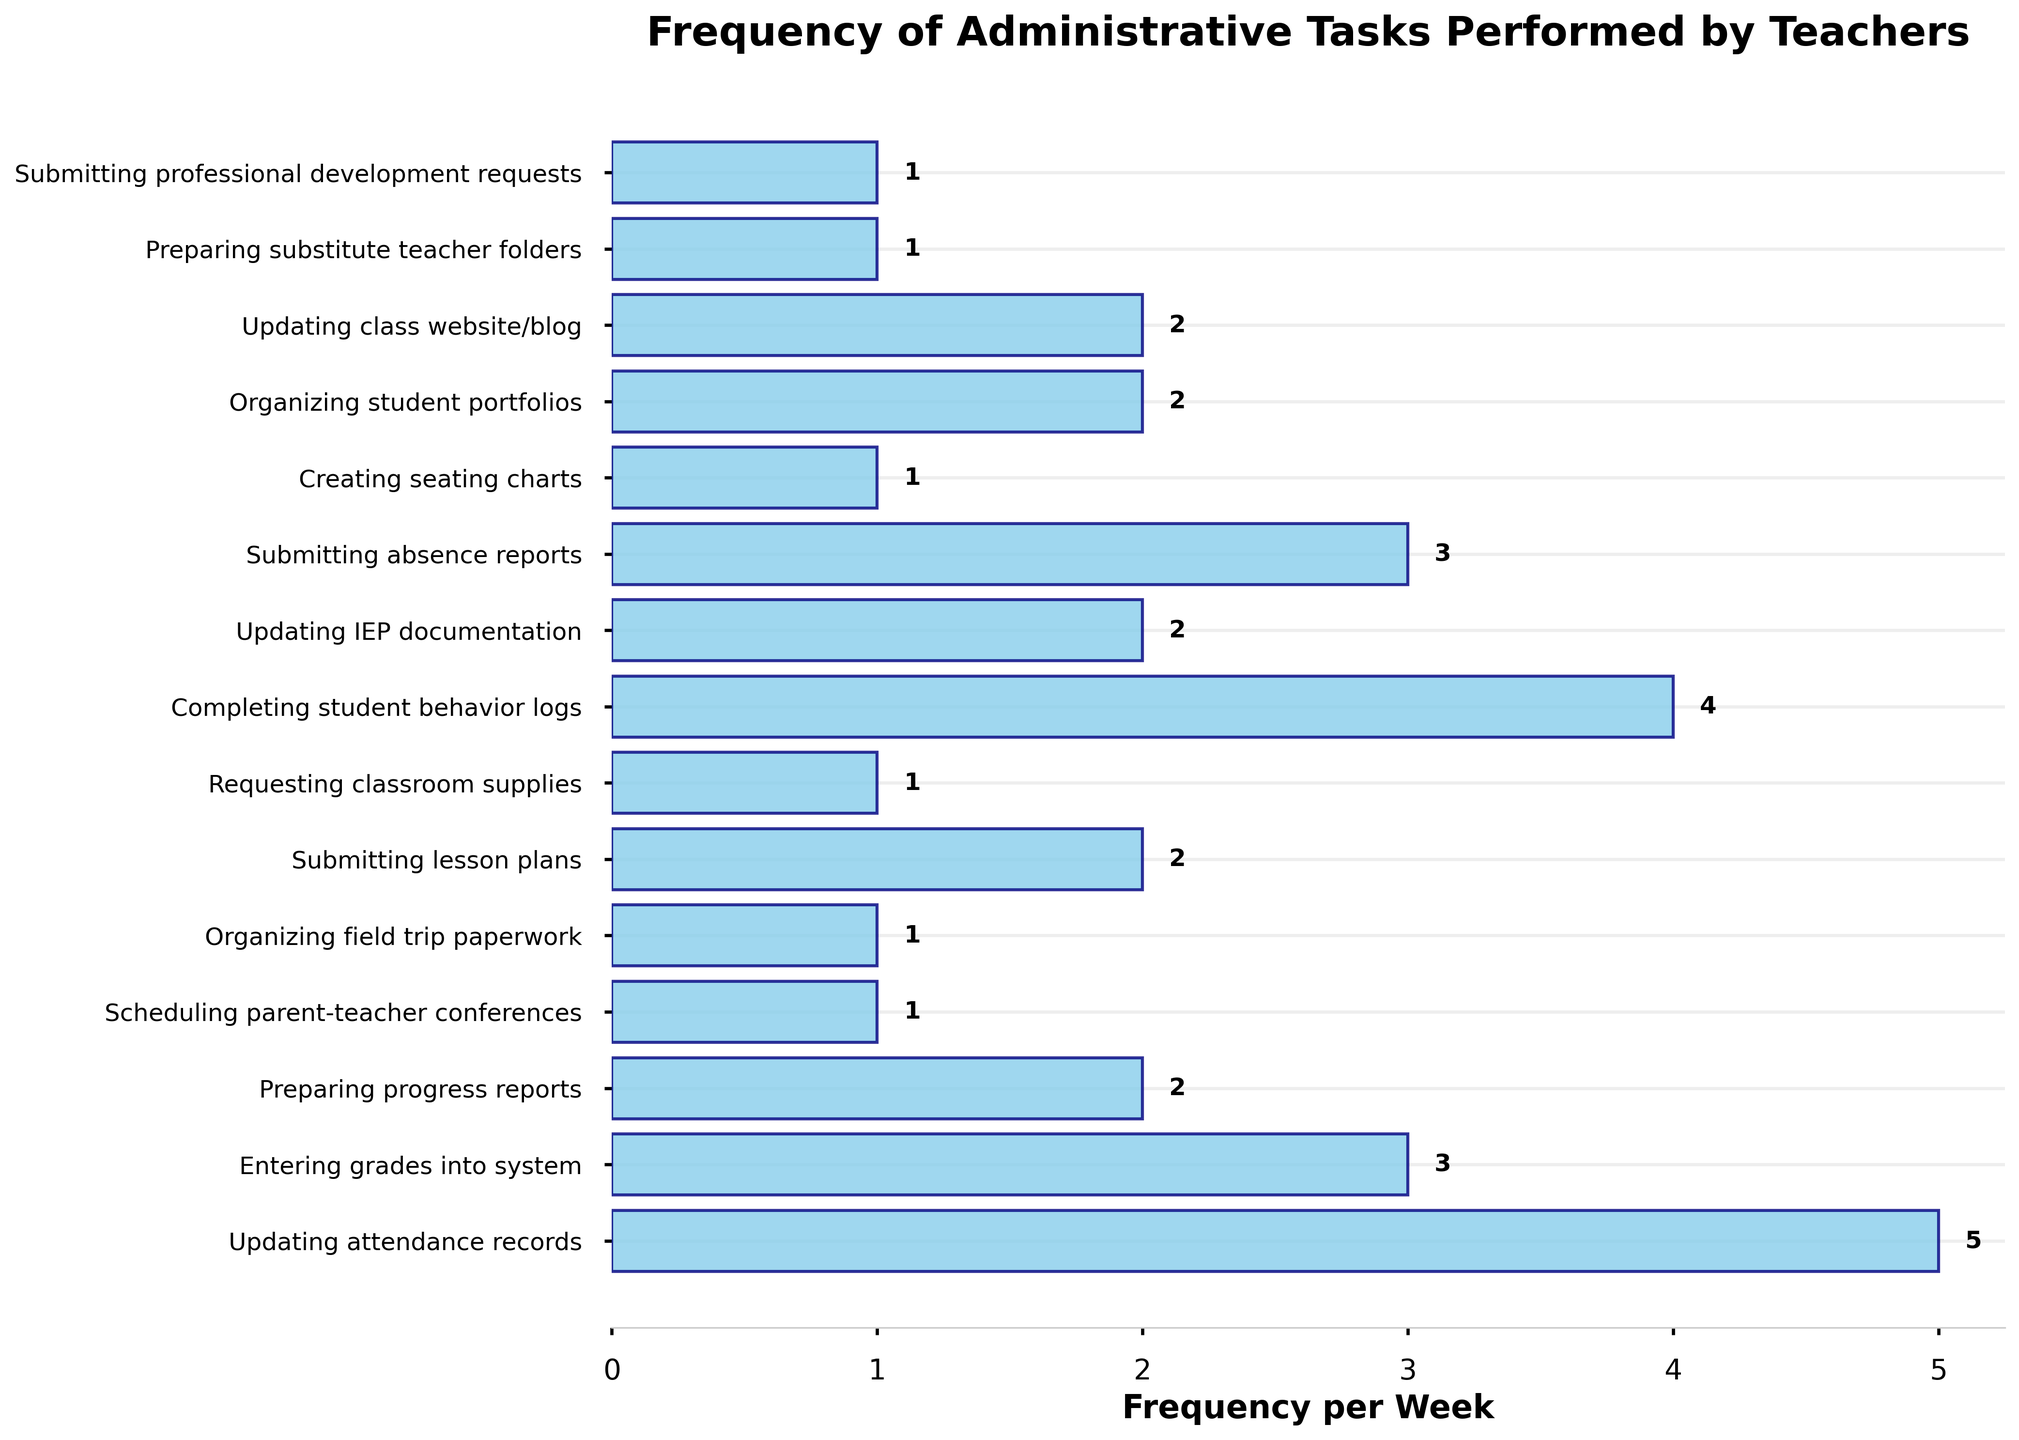What's the most frequently performed administrative task per week? The most frequently performed administrative task is represented by the longest bar on the chart.
Answer: Updating attendance records Which two administrative tasks have the same frequency and what is that frequency? Looking at the chart, the bars indicating 2 occurrences per week are labeled as Preparing progress reports, Updating IEP documentation, Submitting lesson plans, Organizing student portfolios, and Updating class website/blog, which means they all have the same frequency of being performed twice per week.
Answer: 5 tasks, of frequency 2 Is the frequency of entering grades into the system greater than submitting lesson plans? The height of the bar for entering grades into the system indicates a frequency of 3, while the bar for submitting lesson plans indicates a frequency of 2. Thereby, entering grades into the system has a greater frequency.
Answer: Yes What is the sum of the frequencies of the three least frequent tasks? The three least frequent tasks are Scheduling parent-teacher conferences, Organizing field trip paperwork, and Creating seating charts, each with a frequency of 1. Summing these frequencies: 1 + 1 + 1 = 3.
Answer: 3 Which tasks have a frequency equal to 1 and fall at the bottom of the ranking? The tasks with frequencies equal to 1 are Scheduling parent-teacher conferences, Organizing field trip paperwork, Requesting classroom supplies, Creating seating charts, Preparing substitute teacher folders, and Submitting professional development requests. These are located toward the bottom of the chart.
Answer: Scheduling parent-teacher conferences, Organizing field trip paperwork, Requesting classroom supplies, Creating seating charts, Preparing substitute teacher folders, Submitting professional development requests Are there any tasks with a frequency twice that of submitting absence reports? Submitting absence reports have a frequency of 3. No task has a frequency of 6 (3 * 2).
Answer: No How many tasks have a frequency greater than or equal to 3? Count the number of bars with frequencies of 3 or higher. These are Updating attendance records (5), Entering grades into system (3), Completing student behavior logs (4), and Submitting absence reports (3). There are 4 tasks in total.
Answer: 4 What's the difference in frequency between the most and least performed tasks? The most performed task is Updating attendance records with a frequency of 5, and the least performed tasks (multiple) have a frequency of 1. The difference is 5 - 1 = 4.
Answer: 4 On average, how frequently are tasks performed weekly? Summing up all frequencies gives: 5 + 3 + 2 + 1 + 1 + 2 + 1 + 4 + 2 + 3 + 1 + 2 + 2 + 1 + 1 = 31. There are 15 tasks: 31 / 15 = approximately 2.07
Answer: Approximately 2.07 